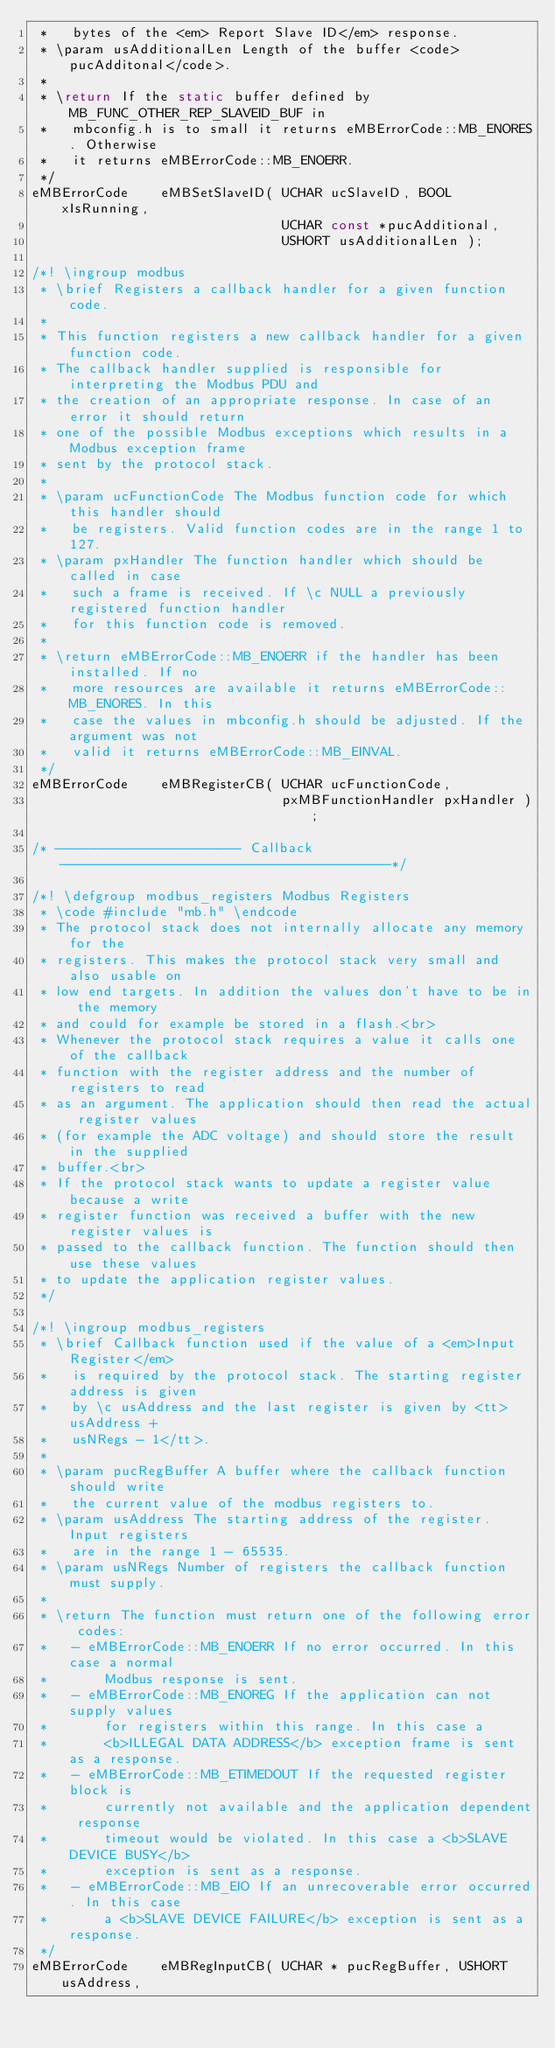Convert code to text. <code><loc_0><loc_0><loc_500><loc_500><_C_> *   bytes of the <em> Report Slave ID</em> response.
 * \param usAdditionalLen Length of the buffer <code>pucAdditonal</code>.
 *
 * \return If the static buffer defined by MB_FUNC_OTHER_REP_SLAVEID_BUF in
 *   mbconfig.h is to small it returns eMBErrorCode::MB_ENORES. Otherwise
 *   it returns eMBErrorCode::MB_ENOERR.
 */
eMBErrorCode    eMBSetSlaveID( UCHAR ucSlaveID, BOOL xIsRunning,
                               UCHAR const *pucAdditional,
                               USHORT usAdditionalLen );

/*! \ingroup modbus
 * \brief Registers a callback handler for a given function code.
 *
 * This function registers a new callback handler for a given function code.
 * The callback handler supplied is responsible for interpreting the Modbus PDU and
 * the creation of an appropriate response. In case of an error it should return
 * one of the possible Modbus exceptions which results in a Modbus exception frame
 * sent by the protocol stack. 
 *
 * \param ucFunctionCode The Modbus function code for which this handler should
 *   be registers. Valid function codes are in the range 1 to 127.
 * \param pxHandler The function handler which should be called in case
 *   such a frame is received. If \c NULL a previously registered function handler
 *   for this function code is removed.
 *
 * \return eMBErrorCode::MB_ENOERR if the handler has been installed. If no
 *   more resources are available it returns eMBErrorCode::MB_ENORES. In this
 *   case the values in mbconfig.h should be adjusted. If the argument was not
 *   valid it returns eMBErrorCode::MB_EINVAL.
 */
eMBErrorCode    eMBRegisterCB( UCHAR ucFunctionCode, 
                               pxMBFunctionHandler pxHandler );

/* ----------------------- Callback -----------------------------------------*/

/*! \defgroup modbus_registers Modbus Registers
 * \code #include "mb.h" \endcode
 * The protocol stack does not internally allocate any memory for the
 * registers. This makes the protocol stack very small and also usable on
 * low end targets. In addition the values don't have to be in the memory
 * and could for example be stored in a flash.<br>
 * Whenever the protocol stack requires a value it calls one of the callback
 * function with the register address and the number of registers to read
 * as an argument. The application should then read the actual register values
 * (for example the ADC voltage) and should store the result in the supplied
 * buffer.<br>
 * If the protocol stack wants to update a register value because a write
 * register function was received a buffer with the new register values is
 * passed to the callback function. The function should then use these values
 * to update the application register values.
 */

/*! \ingroup modbus_registers
 * \brief Callback function used if the value of a <em>Input Register</em>
 *   is required by the protocol stack. The starting register address is given
 *   by \c usAddress and the last register is given by <tt>usAddress +
 *   usNRegs - 1</tt>.
 *
 * \param pucRegBuffer A buffer where the callback function should write
 *   the current value of the modbus registers to.
 * \param usAddress The starting address of the register. Input registers
 *   are in the range 1 - 65535.
 * \param usNRegs Number of registers the callback function must supply.
 *
 * \return The function must return one of the following error codes:
 *   - eMBErrorCode::MB_ENOERR If no error occurred. In this case a normal
 *       Modbus response is sent.
 *   - eMBErrorCode::MB_ENOREG If the application can not supply values
 *       for registers within this range. In this case a 
 *       <b>ILLEGAL DATA ADDRESS</b> exception frame is sent as a response.
 *   - eMBErrorCode::MB_ETIMEDOUT If the requested register block is
 *       currently not available and the application dependent response
 *       timeout would be violated. In this case a <b>SLAVE DEVICE BUSY</b>
 *       exception is sent as a response.
 *   - eMBErrorCode::MB_EIO If an unrecoverable error occurred. In this case
 *       a <b>SLAVE DEVICE FAILURE</b> exception is sent as a response.
 */
eMBErrorCode    eMBRegInputCB( UCHAR * pucRegBuffer, USHORT usAddress,</code> 